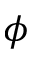<formula> <loc_0><loc_0><loc_500><loc_500>\phi</formula> 